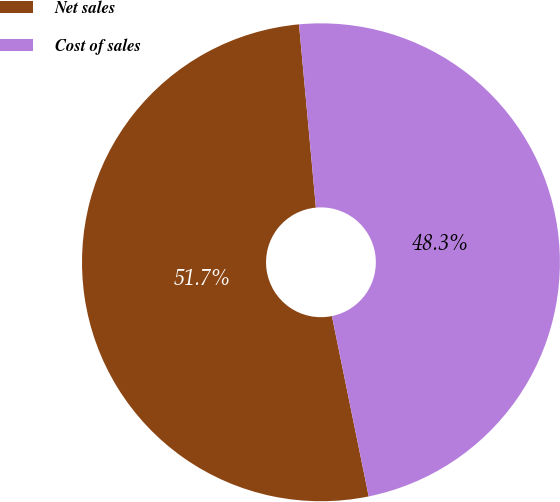Convert chart. <chart><loc_0><loc_0><loc_500><loc_500><pie_chart><fcel>Net sales<fcel>Cost of sales<nl><fcel>51.74%<fcel>48.26%<nl></chart> 